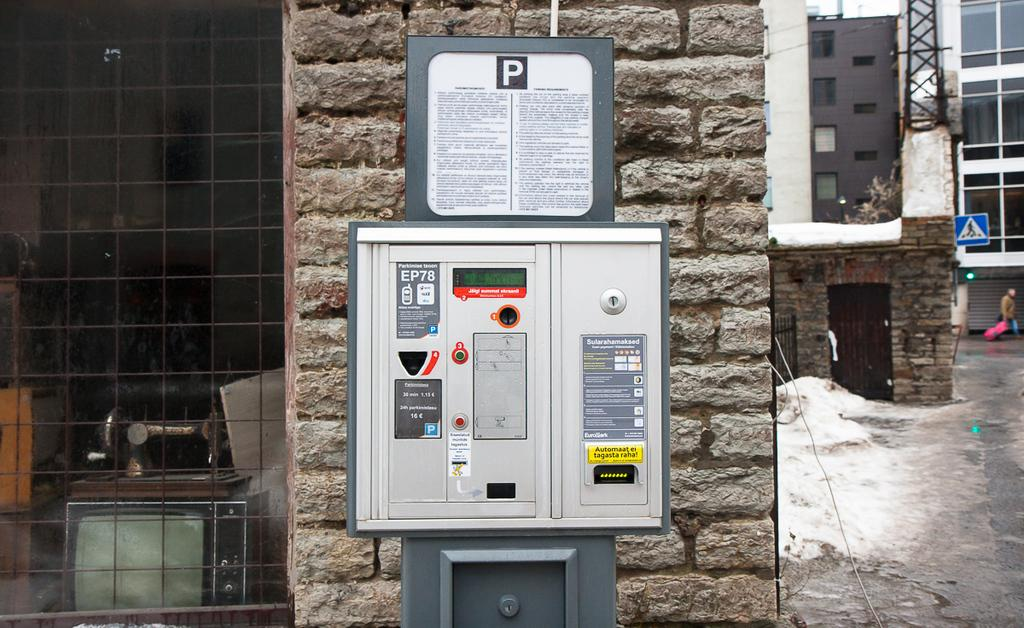<image>
Describe the image concisely. A machine where you can pay for parking in Europe is on a brick wall. 